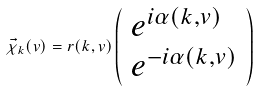Convert formula to latex. <formula><loc_0><loc_0><loc_500><loc_500>\vec { \chi } _ { k } ( v ) = r ( k , v ) \left ( \begin{array} { l } e ^ { i \alpha ( k , v ) } \\ e ^ { - i \alpha ( k , v ) } \end{array} \right )</formula> 